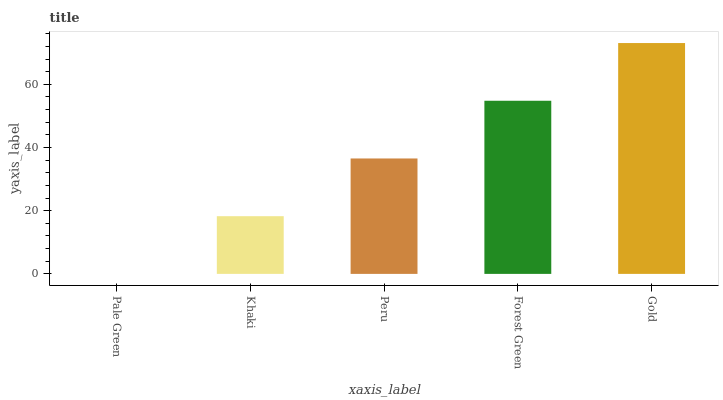Is Khaki the minimum?
Answer yes or no. No. Is Khaki the maximum?
Answer yes or no. No. Is Khaki greater than Pale Green?
Answer yes or no. Yes. Is Pale Green less than Khaki?
Answer yes or no. Yes. Is Pale Green greater than Khaki?
Answer yes or no. No. Is Khaki less than Pale Green?
Answer yes or no. No. Is Peru the high median?
Answer yes or no. Yes. Is Peru the low median?
Answer yes or no. Yes. Is Gold the high median?
Answer yes or no. No. Is Forest Green the low median?
Answer yes or no. No. 